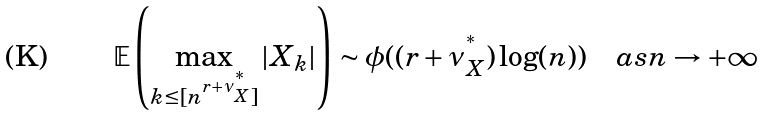<formula> <loc_0><loc_0><loc_500><loc_500>\mathbb { E } \left ( \max _ { k \leq [ n ^ { r + \nu ^ { ^ { * } } _ { X } } ] } | X _ { k } | \right ) \sim \phi ( ( r + \nu ^ { ^ { * } } _ { X } ) \log ( n ) ) \quad a s n \rightarrow + \infty</formula> 